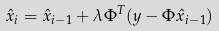<formula> <loc_0><loc_0><loc_500><loc_500>\hat { x } _ { i } = \hat { x } _ { i - 1 } + \lambda \Phi ^ { T } ( y - \Phi \hat { x } _ { i - 1 } )</formula> 